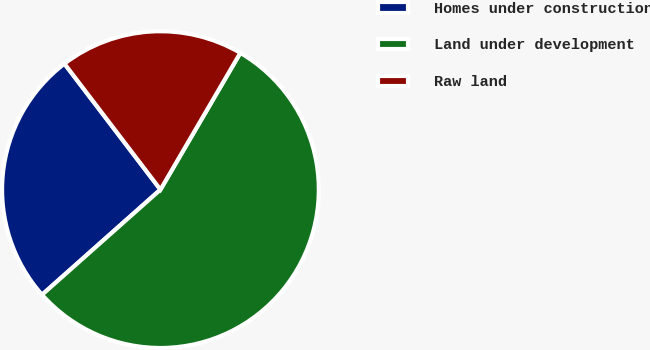Convert chart to OTSL. <chart><loc_0><loc_0><loc_500><loc_500><pie_chart><fcel>Homes under construction<fcel>Land under development<fcel>Raw land<nl><fcel>26.19%<fcel>55.03%<fcel>18.78%<nl></chart> 